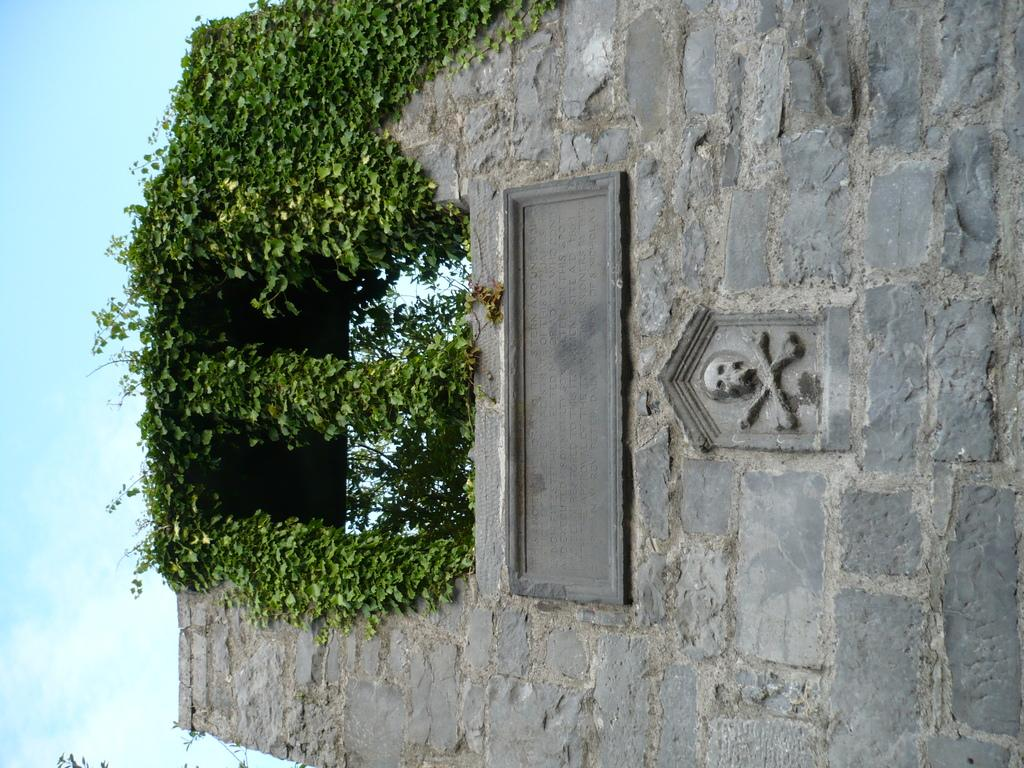What is located in the foreground of the image? There is a stone wall in the foreground of the image. What type of vegetation is growing on the stone wall? Creepers are present on the stone wall. What can be seen on the left side of the image? The sky is visible on the left side of the image. How does the beggar move in the image? There is no beggar present in the image. What type of answer is given by the stone wall in the image? The stone wall does not provide any answers in the image, as it is an inanimate object. 